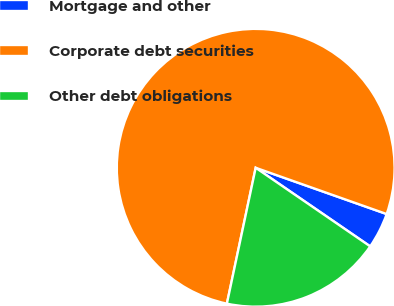Convert chart to OTSL. <chart><loc_0><loc_0><loc_500><loc_500><pie_chart><fcel>Mortgage and other<fcel>Corporate debt securities<fcel>Other debt obligations<nl><fcel>4.17%<fcel>77.08%<fcel>18.75%<nl></chart> 